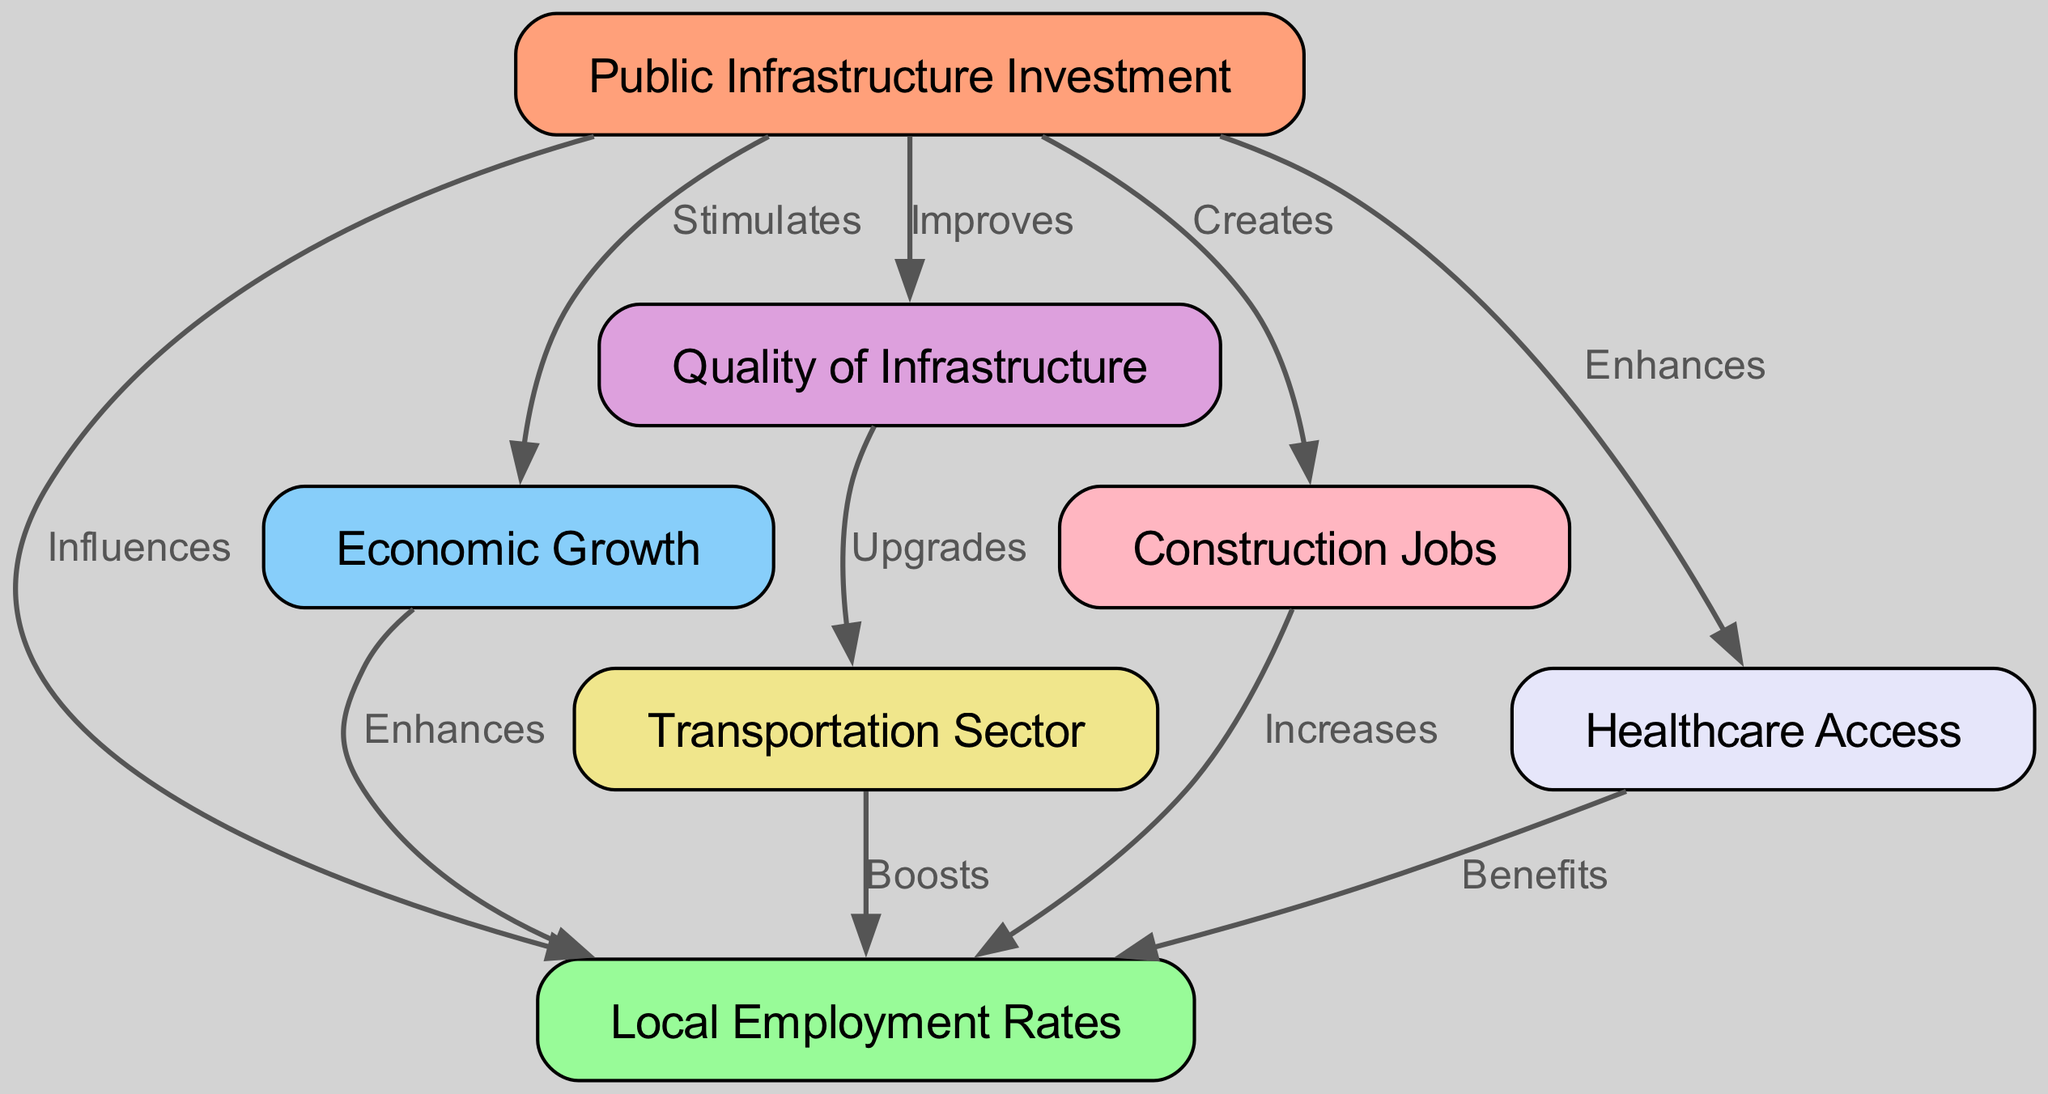What are the two primary nodes connected by the edge labeled "Influences"? The edge labeled "Influences" connects the nodes "Public Infrastructure Investment" and "Local Employment Rates". The diagram indicates this direct relationship that suggests how one impacts the other.
Answer: Public Infrastructure Investment, Local Employment Rates How many nodes are present in the diagram? To find the total number of nodes, we count all unique nodes listed in the data provided. There are seven distinct nodes in total representing various aspects of public infrastructure and employment.
Answer: 7 What label connects "Economic Growth" to "Local Employment Rates"? The label "Enhances" indicates the relationship where "Economic Growth" has a positive effect on "Local Employment Rates", demonstrating how growth contributes to employment.
Answer: Enhances Which node is directly influenced by "Quality of Infrastructure"? The node "Transportation Sector" is influenced by "Quality of Infrastructure". According to the diagram, improvements in infrastructure quality lead to upgrades in the transportation sector.
Answer: Transportation Sector How many edges are there linking from "Public Infrastructure Investment"? By examining the edges, we see that there are five edges originating from "Public Infrastructure Investment", indicating various impacts it has on other aspects like employment, economic growth, and healthcare access.
Answer: 5 What outcome does "Healthcare Access" provide to "Local Employment Rates"? The label "Benefits" denotes the positive relationship where enhanced healthcare access contributes to an increase in local employment rates by improving overall community well-being and productivity.
Answer: Benefits Explain the flow from "Public Infrastructure Investment" to "Local Employment Rates". Starting from "Public Infrastructure Investment", it first influences "Local Employment Rates" directly, but also stimulates "Economic Growth". This economic growth subsequently enhances "Local Employment Rates". Additionally, it creates "Construction Jobs", which further increases local employment. Thus, there are multiple paths through which public infrastructure investment impacts local employment.
Answer: Multiple paths What is created as a result of "Public Infrastructure Investment"? The creation of "Construction Jobs" is a direct result of investments in public infrastructure, highlighting the immediate job opportunities generated within the construction sector as infrastructure projects are initiated.
Answer: Construction Jobs 